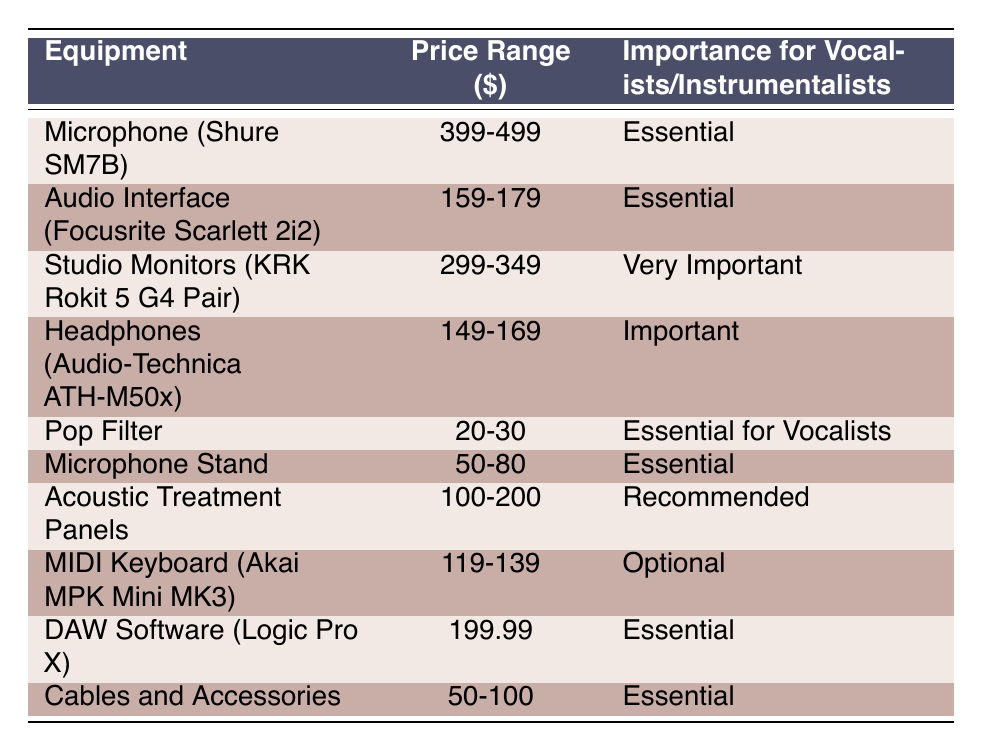What is the price range for the Shure SM7B microphone? The table shows that the price range for the Shure SM7B microphone is listed under the "Price Range ($)" column, which states 399-499.
Answer: 399-499 Which equipment is considered essential for vocalists based on the table? The table identifies several items under the "Importance for Vocalists/Instrumentalists" column marked as "Essential." These items include the Microphone, Pop Filter, Microphone Stand, DAW Software, and Cables and Accessories.
Answer: Microphone, Pop Filter, Microphone Stand, DAW Software, Cables and Accessories What is the total price range for both the Audio Interface and the MIDI Keyboard? The price range for the Audio Interface (Focusrite Scarlett 2i2) is 159-179, and for the MIDI Keyboard (Akai MPK Mini MK3) is 119-139. To find the total price range, we sum the lower ends (159 + 119 = 278) and the upper ends (179 + 139 = 318), resulting in a total range of 278-318.
Answer: 278-318 Is the Logic Pro X DAW Software considered optional? The table indicates that Logic Pro X is labeled as "Essential" under the "Importance for Vocalists/Instrumentalists," which means it is not optional.
Answer: No How many equipment items are classified as "Very Important"? The table shows that only one item, the Studio Monitors (KRK Rokit 5 G4 Pair), is categorized as "Very Important" in the importance column.
Answer: 1 What is the average price range for the equipment that is classified as essential? The prices for essential equipment items are 399-499 (Microphone), 159-179 (Audio Interface), 20-30 (Pop Filter), 50-80 (Microphone Stand), 199.99 (DAW Software), and 50-100 (Cables and Accessories). To find the average, we first find the combined price ranges: lower ends: 399 + 159 + 20 + 50 + 199.99 + 50 = 877.99; upper ends: 499 + 179 + 30 + 80 + 199.99 + 100 = 1088.99. The average would then be computed by finding the total and dividing by the number of items (6): (877.99 + 1088.99) / 2 = 983.99 / 6 = approximately 163.995 per item or 164 rounded.
Answer: 164 Are headphones essential according to the importance classification? The table lists the Headphones (Audio-Technica ATH-M50x) as "Important," which is not classified as "Essential" according to the importance label in the table.
Answer: No What is the difference in the price range between the Studio Monitors and the Acoustic Treatment Panels? The price range for Studio Monitors is 299-349, and for Acoustic Treatment Panels, it is 100-200. The difference for the lower ends is 299 - 100 = 199 and for the upper ends is 349 - 200 = 149. The full price difference would be from 199 to 149, reflecting the higher costs associated with Studio Monitors.
Answer: 199-149 